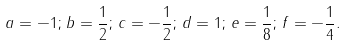<formula> <loc_0><loc_0><loc_500><loc_500>a = - 1 ; \, b = \frac { 1 } { 2 } ; \, c = - \frac { 1 } { 2 } ; \, d = 1 ; \, e = \frac { 1 } { 8 } ; \, f = - \frac { 1 } { 4 } .</formula> 